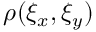Convert formula to latex. <formula><loc_0><loc_0><loc_500><loc_500>\rho ( \xi _ { x } , \xi _ { y } )</formula> 